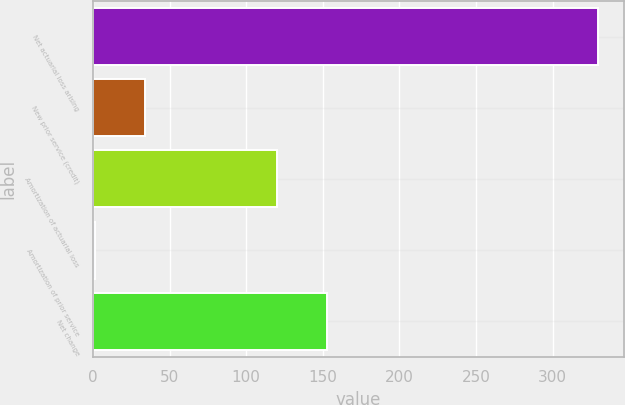<chart> <loc_0><loc_0><loc_500><loc_500><bar_chart><fcel>Net actuarial loss arising<fcel>New prior service (credit)<fcel>Amortization of actuarial loss<fcel>Amortization of prior service<fcel>Net change<nl><fcel>330<fcel>33.9<fcel>120<fcel>1<fcel>152.9<nl></chart> 